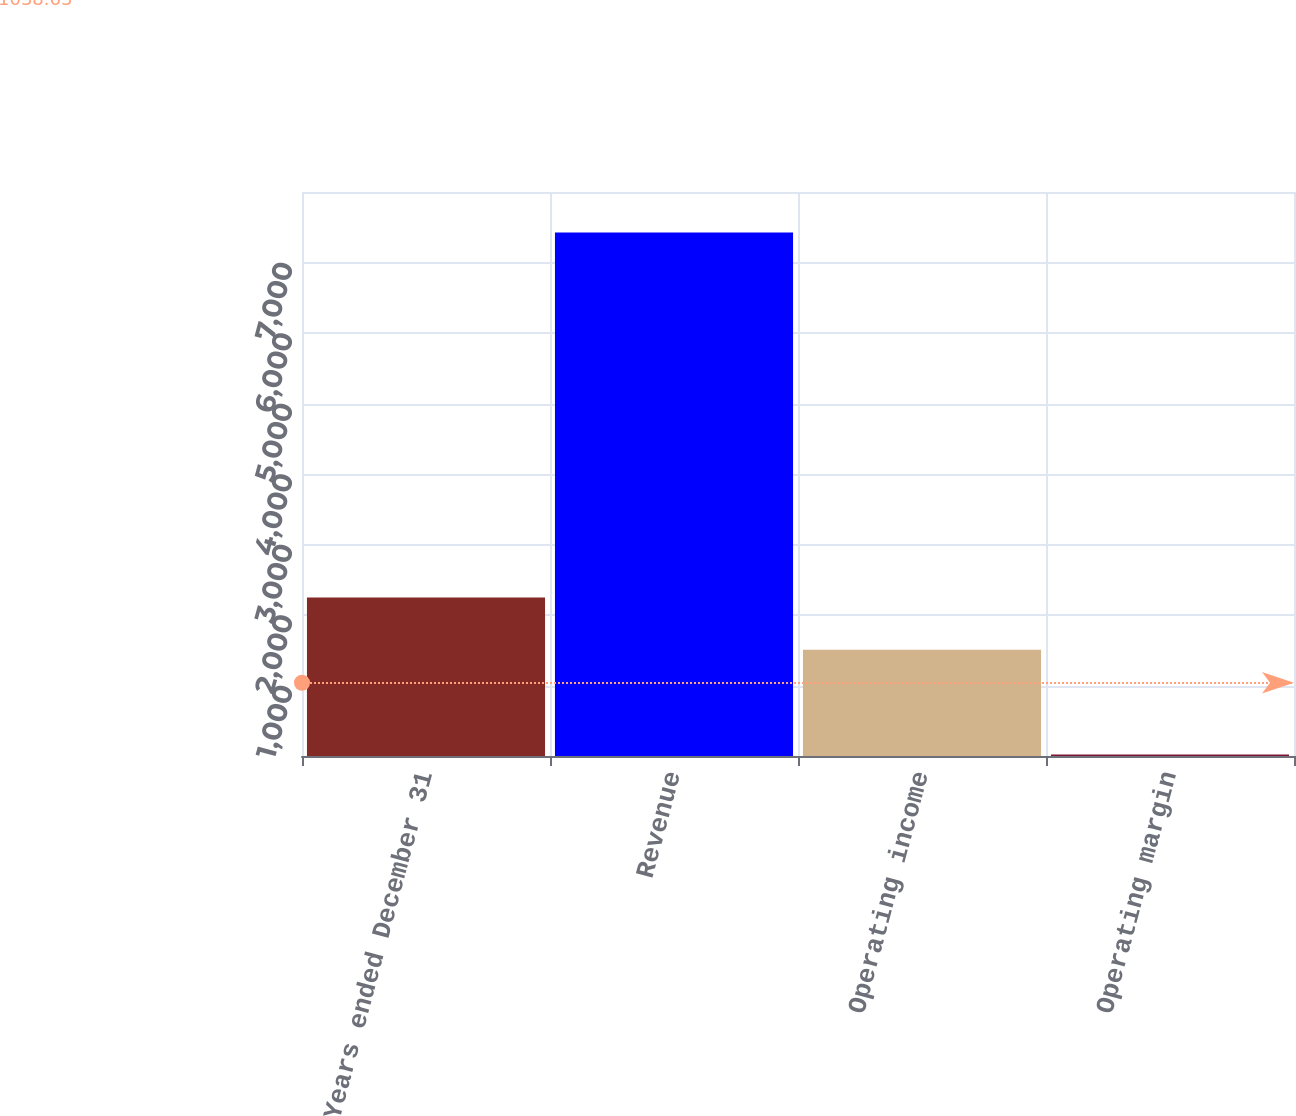Convert chart to OTSL. <chart><loc_0><loc_0><loc_500><loc_500><bar_chart><fcel>Years ended December 31<fcel>Revenue<fcel>Operating income<fcel>Operating margin<nl><fcel>2246.57<fcel>7426<fcel>1506<fcel>20.3<nl></chart> 